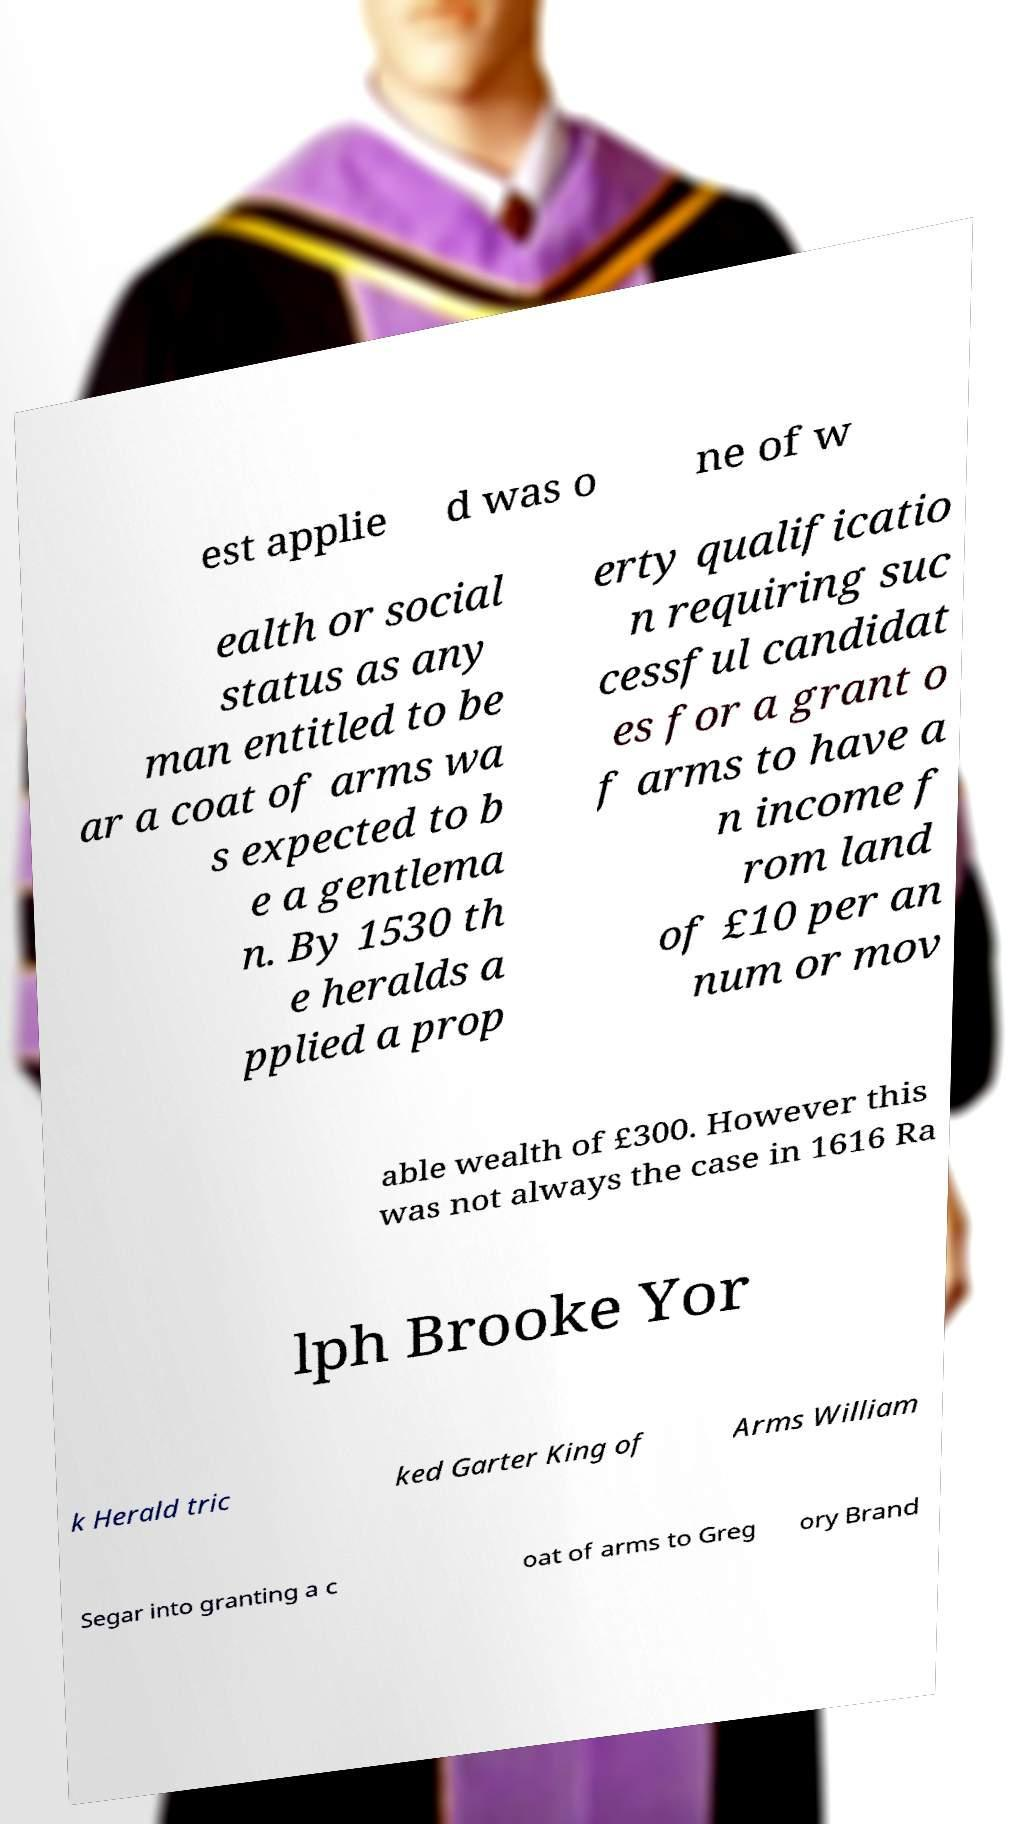Please read and relay the text visible in this image. What does it say? est applie d was o ne of w ealth or social status as any man entitled to be ar a coat of arms wa s expected to b e a gentlema n. By 1530 th e heralds a pplied a prop erty qualificatio n requiring suc cessful candidat es for a grant o f arms to have a n income f rom land of £10 per an num or mov able wealth of £300. However this was not always the case in 1616 Ra lph Brooke Yor k Herald tric ked Garter King of Arms William Segar into granting a c oat of arms to Greg ory Brand 